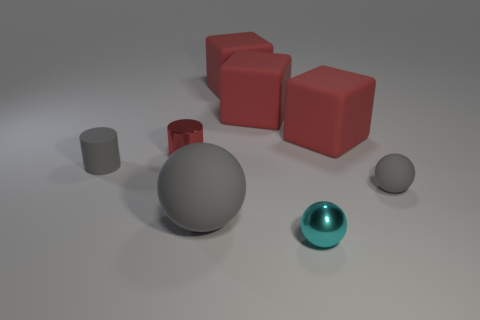Subtract all red cubes. How many were subtracted if there are1red cubes left? 2 Subtract all red cubes. How many gray balls are left? 2 Subtract 1 balls. How many balls are left? 2 Subtract all cyan spheres. How many spheres are left? 2 Add 1 cyan metallic cubes. How many objects exist? 9 Subtract all cylinders. How many objects are left? 6 Subtract all green cubes. Subtract all purple cylinders. How many cubes are left? 3 Subtract 1 cyan balls. How many objects are left? 7 Subtract all large red objects. Subtract all red metallic things. How many objects are left? 4 Add 4 small metallic balls. How many small metallic balls are left? 5 